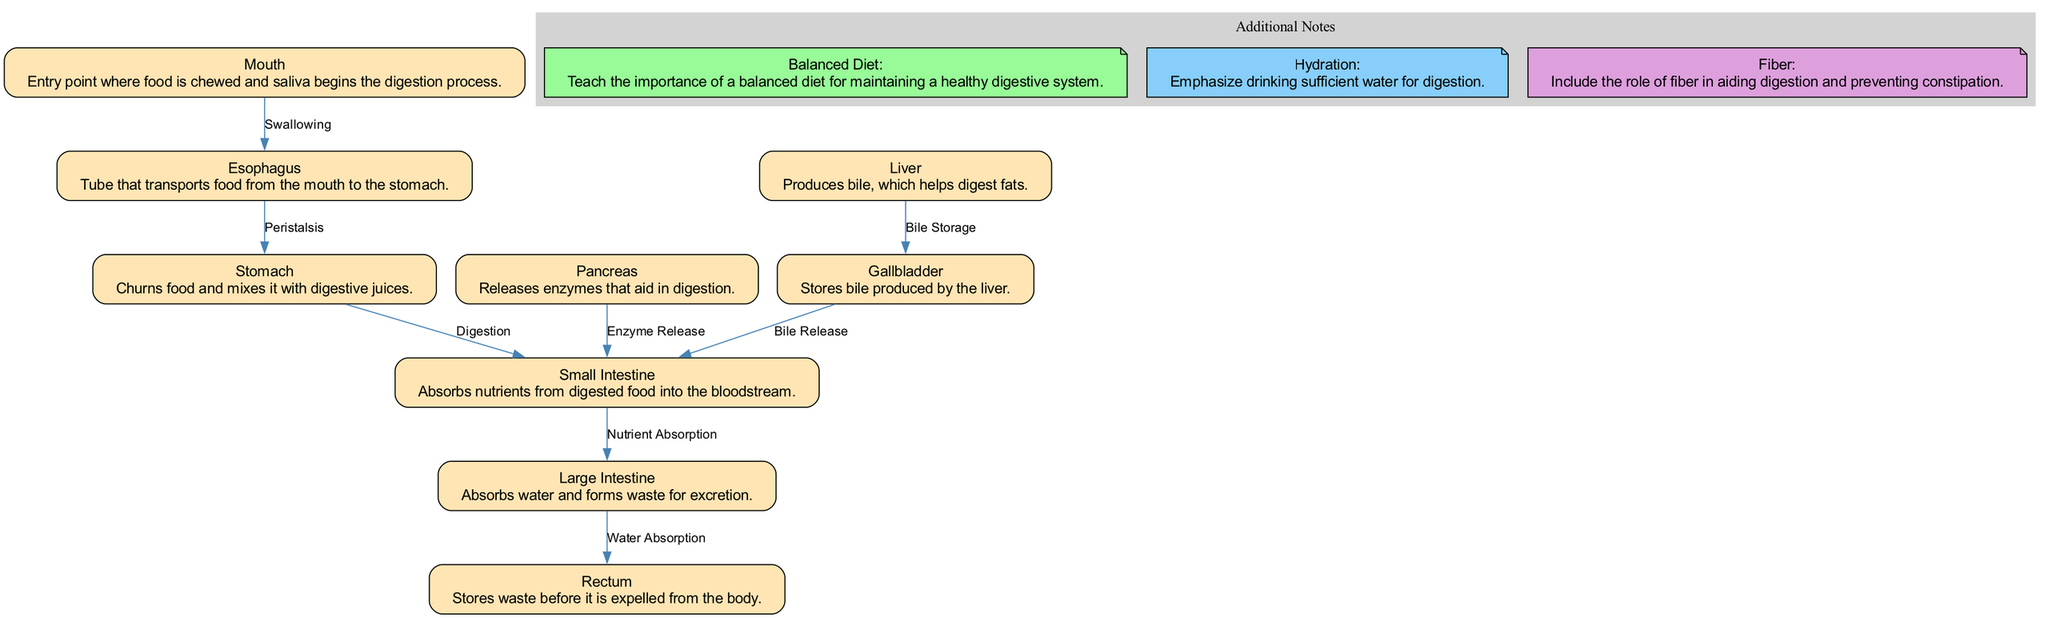What is the first organ in the digestive system? The diagram identifies the "Mouth" as the entry point for food, indicating it is the first organ in the digestive system.
Answer: Mouth How many nodes are there in the diagram? By counting the individual organs and additional notes represented in the diagram, there are a total of 9 nodes.
Answer: 9 What function does the liver perform? According to the diagram, the liver "Produces bile, which helps digest fats," indicating its role in digestion.
Answer: Produces bile Which organ absorbs water? The diagram states that the "Large Intestine" absorbs water before waste is excreted, identifying it as the organ responsible for this function.
Answer: Large Intestine What is the relationship between the pancreas and the small intestine? The diagram indicates that the pancreas releases enzymes, which "aid in digestion" in the small intestine, representing a providing relationship between the two.
Answer: Enzyme Release What is the last step in the digestive process? The diagram outlines that waste storage occurs in the "Rectum," indicating that it is the final step before waste is expelled.
Answer: Rectum How does food move from the mouth to the stomach? The diagram indicates that food moves by "Swallowing" from the mouth to the esophagus and then to the stomach through peristalsis.
Answer: Swallowing Which additional note emphasizes the role of hydration in digestion? The note labeled "Hydration" specifically addresses the importance of drinking sufficient water for digestion, highlighting this concept.
Answer: Hydration What does bile do in the digestive system? The diagram shows that bile, which is produced by the liver and stored in the gallbladder, helps in the digestion of fats.
Answer: Helps digest fats 